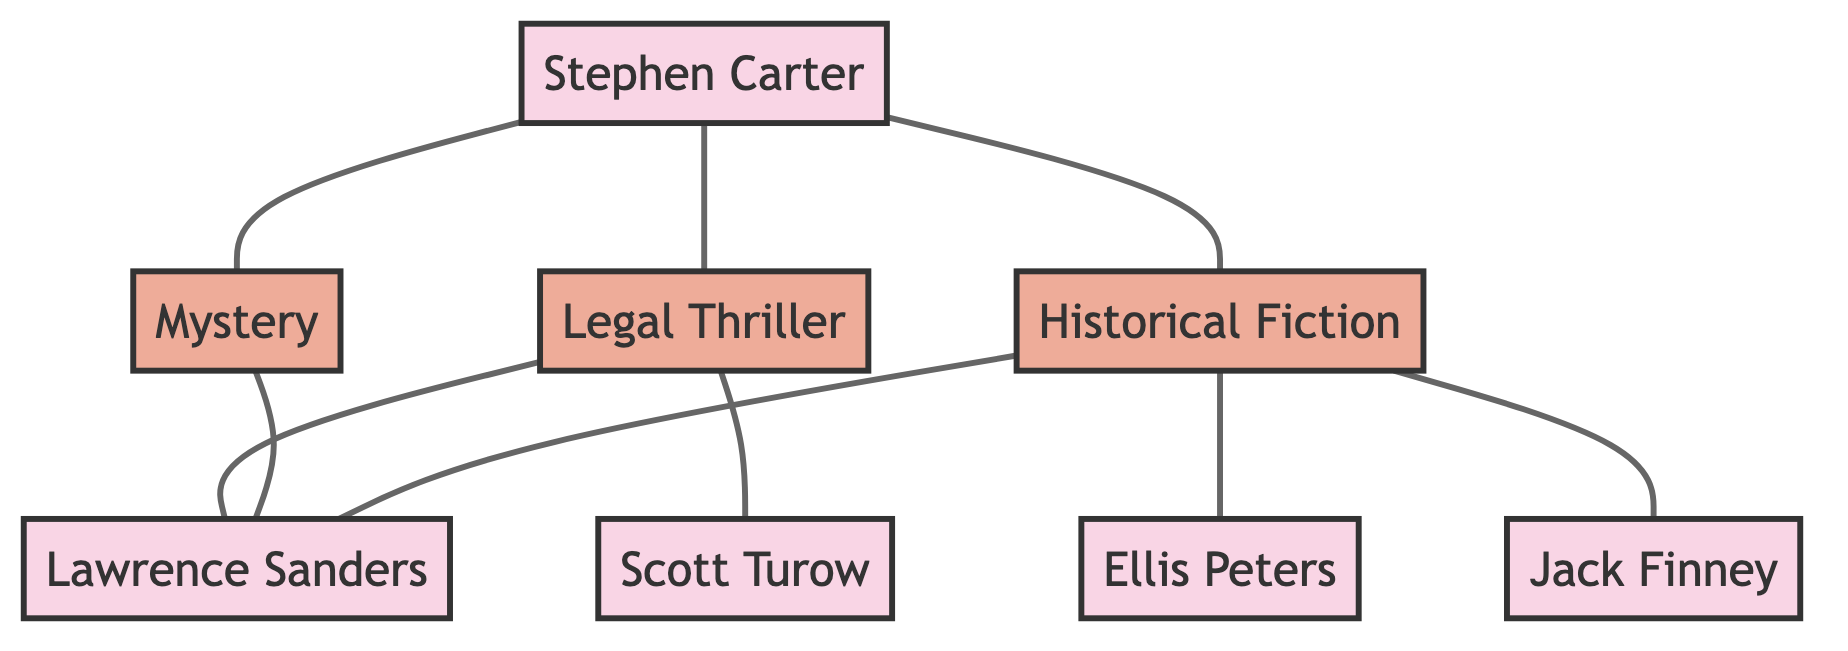What genres is Stephen Carter associated with? In the diagram, the edges connect Stephen Carter to three distinct genres: Legal Thriller, Historical Fiction, and Mystery. These connections indicate that these are the genres associated with him.
Answer: Legal Thriller, Historical Fiction, Mystery Who is connected to both Legal Thriller and Historical Fiction? Examining the edges from both genres, Lawrence Sanders is linked to Legal Thriller and also connected to Historical Fiction. This reveals his dual influence across these two genres.
Answer: Lawrence Sanders How many edges emerge from the Historical Fiction node? By counting the edges linked to the Historical Fiction node, we can see it is connected to two authors: Ellis Peters and Jack Finney, plus an additional connection to Lawrence Sanders. Therefore, there are three edges in total.
Answer: 3 What are the genres associated with Lawrence Sanders? Tracing the edges connected to Lawrence Sanders reveals he is associated with both Legal Thriller and Mystery, as he has edges connecting from these genres to him.
Answer: Legal Thriller, Mystery Which author is connected to the most genres? Analyzing the diagram, Stephen Carter is linked to three genres (Legal Thriller, Historical Fiction, Mystery), more than any other author. The other authors have fewer connections, making Stephen Carter the author connected to the most genres.
Answer: Stephen Carter How many authors have connections to the Mystery genre? The Mystery genre node has two connections: one to Lawrence Sanders and another to Stephen Carter, indicating that these are the authors associated with this genre.
Answer: 2 Which genre has the fewest connections? By reviewing the nodes and their edges, the Historical Fiction node has a total of three connections, while the other two genres connect with two authors each. Therefore, the genre with the fewer connections is Legal Thriller and Mystery, both having two connections.
Answer: Legal Thriller, Mystery Which author has connections across both genres and has titles associated with Stephen Carter? From the diagram, Lawrence Sanders has connections to both Legal Thriller and Mystery, indicating his influence across genres associated with Stephen Carter.
Answer: Lawrence Sanders 